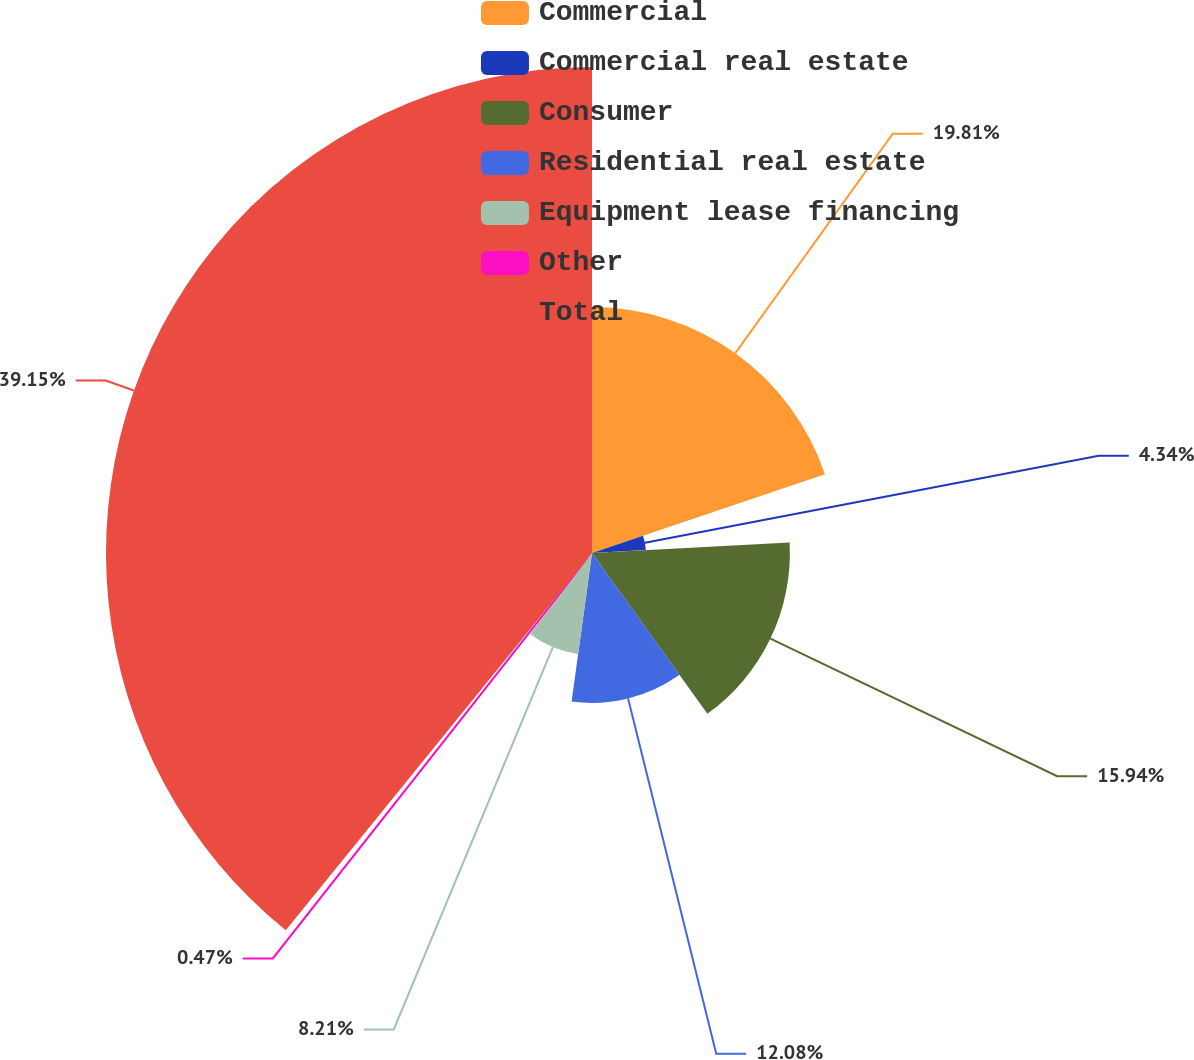Convert chart. <chart><loc_0><loc_0><loc_500><loc_500><pie_chart><fcel>Commercial<fcel>Commercial real estate<fcel>Consumer<fcel>Residential real estate<fcel>Equipment lease financing<fcel>Other<fcel>Total<nl><fcel>19.81%<fcel>4.34%<fcel>15.94%<fcel>12.08%<fcel>8.21%<fcel>0.47%<fcel>39.15%<nl></chart> 